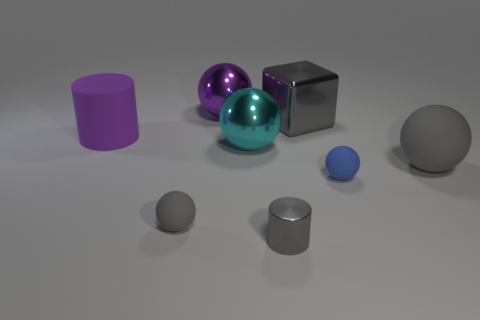Can you describe the colors of the items showcased? Certainly! The image displays objects in various colors: we have a purple cylinder, a teal sphere, a shiny metallic cube, two gray spheres of different sizes, a smaller silver cylinder, and a small blue sphere. 